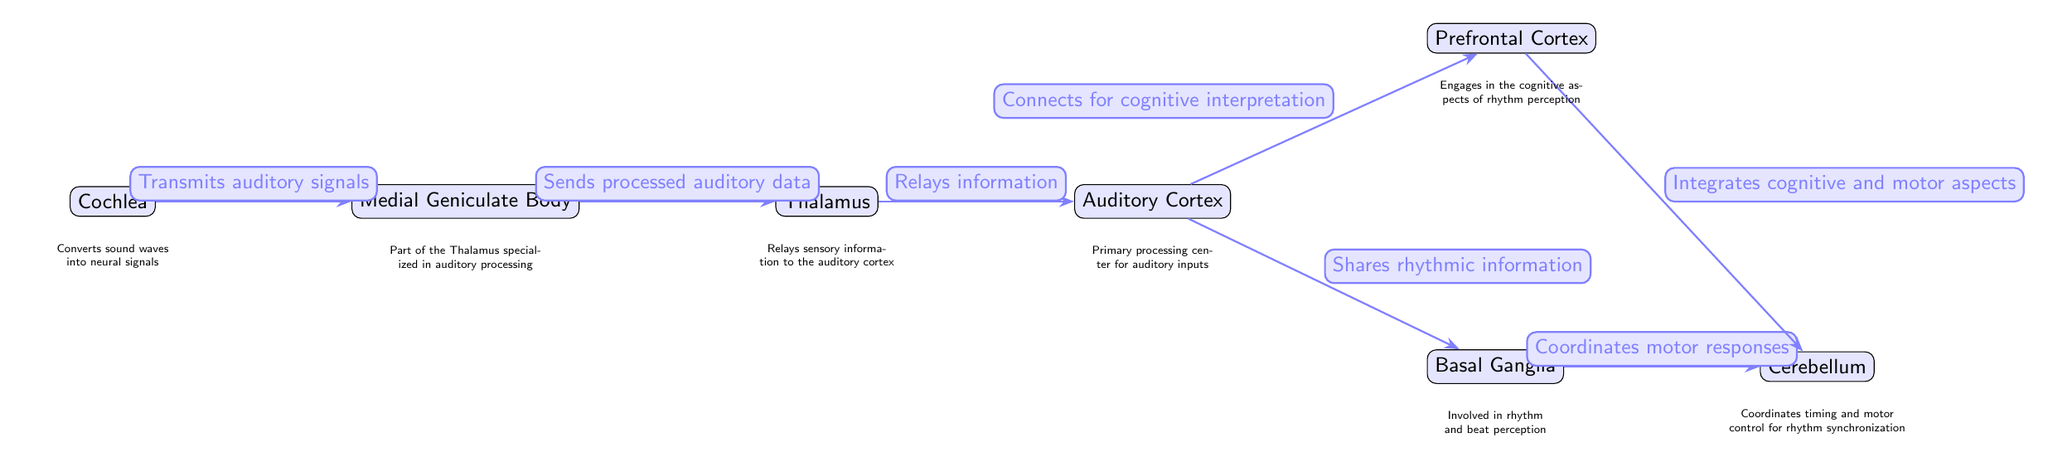What is the first node in the auditory processing pathway? The diagram starts with the Cochlea as the first node, which is responsible for converting sound waves into neural signals.
Answer: Cochlea How many nodes are there in total? The diagram contains a total of seven nodes, including Cochlea, Medial Geniculate Body, Thalamus, Auditory Cortex, Prefrontal Cortex, Basal Ganglia, and Cerebellum.
Answer: Seven Which node shares rhythmic information? The Auditory Cortex is responsible for sharing rhythmic information with the Basal Ganglia.
Answer: Auditory Cortex What does the Medial Geniculate Body do? The Medial Geniculate Body sends processed auditory data to the Thalamus, acting as a relay in the auditory processing pathway.
Answer: Sends processed auditory data Which part of the brain coordinates motor control for rhythm synchronization? The Cerebellum coordinates timing and motor control, aiding in rhythm synchronization.
Answer: Cerebellum Which nodes are directly connected to the Auditory Cortex? The nodes directly connected to the Auditory Cortex are the Thalamus, Basal Ganglia, and Prefrontal Cortex.
Answer: Thalamus, Basal Ganglia, Prefrontal Cortex How does the Basal Ganglia relate to rhythm perception? The Basal Ganglia is involved in rhythm and beat perception, and it coordinates motor responses in conjunction with the Cerebellum.
Answer: Involved in rhythm and beat perception What is the function of the Prefrontal Cortex in this pathway? The Prefrontal Cortex engages in cognitive aspects of rhythm perception, connecting through the Auditory Cortex for interpretation.
Answer: Engages in the cognitive aspects of rhythm perception What type of information does the Thalamus relay? The Thalamus relays sensory information to the auditory cortex, playing a crucial role in auditory processing.
Answer: Relays sensory information 